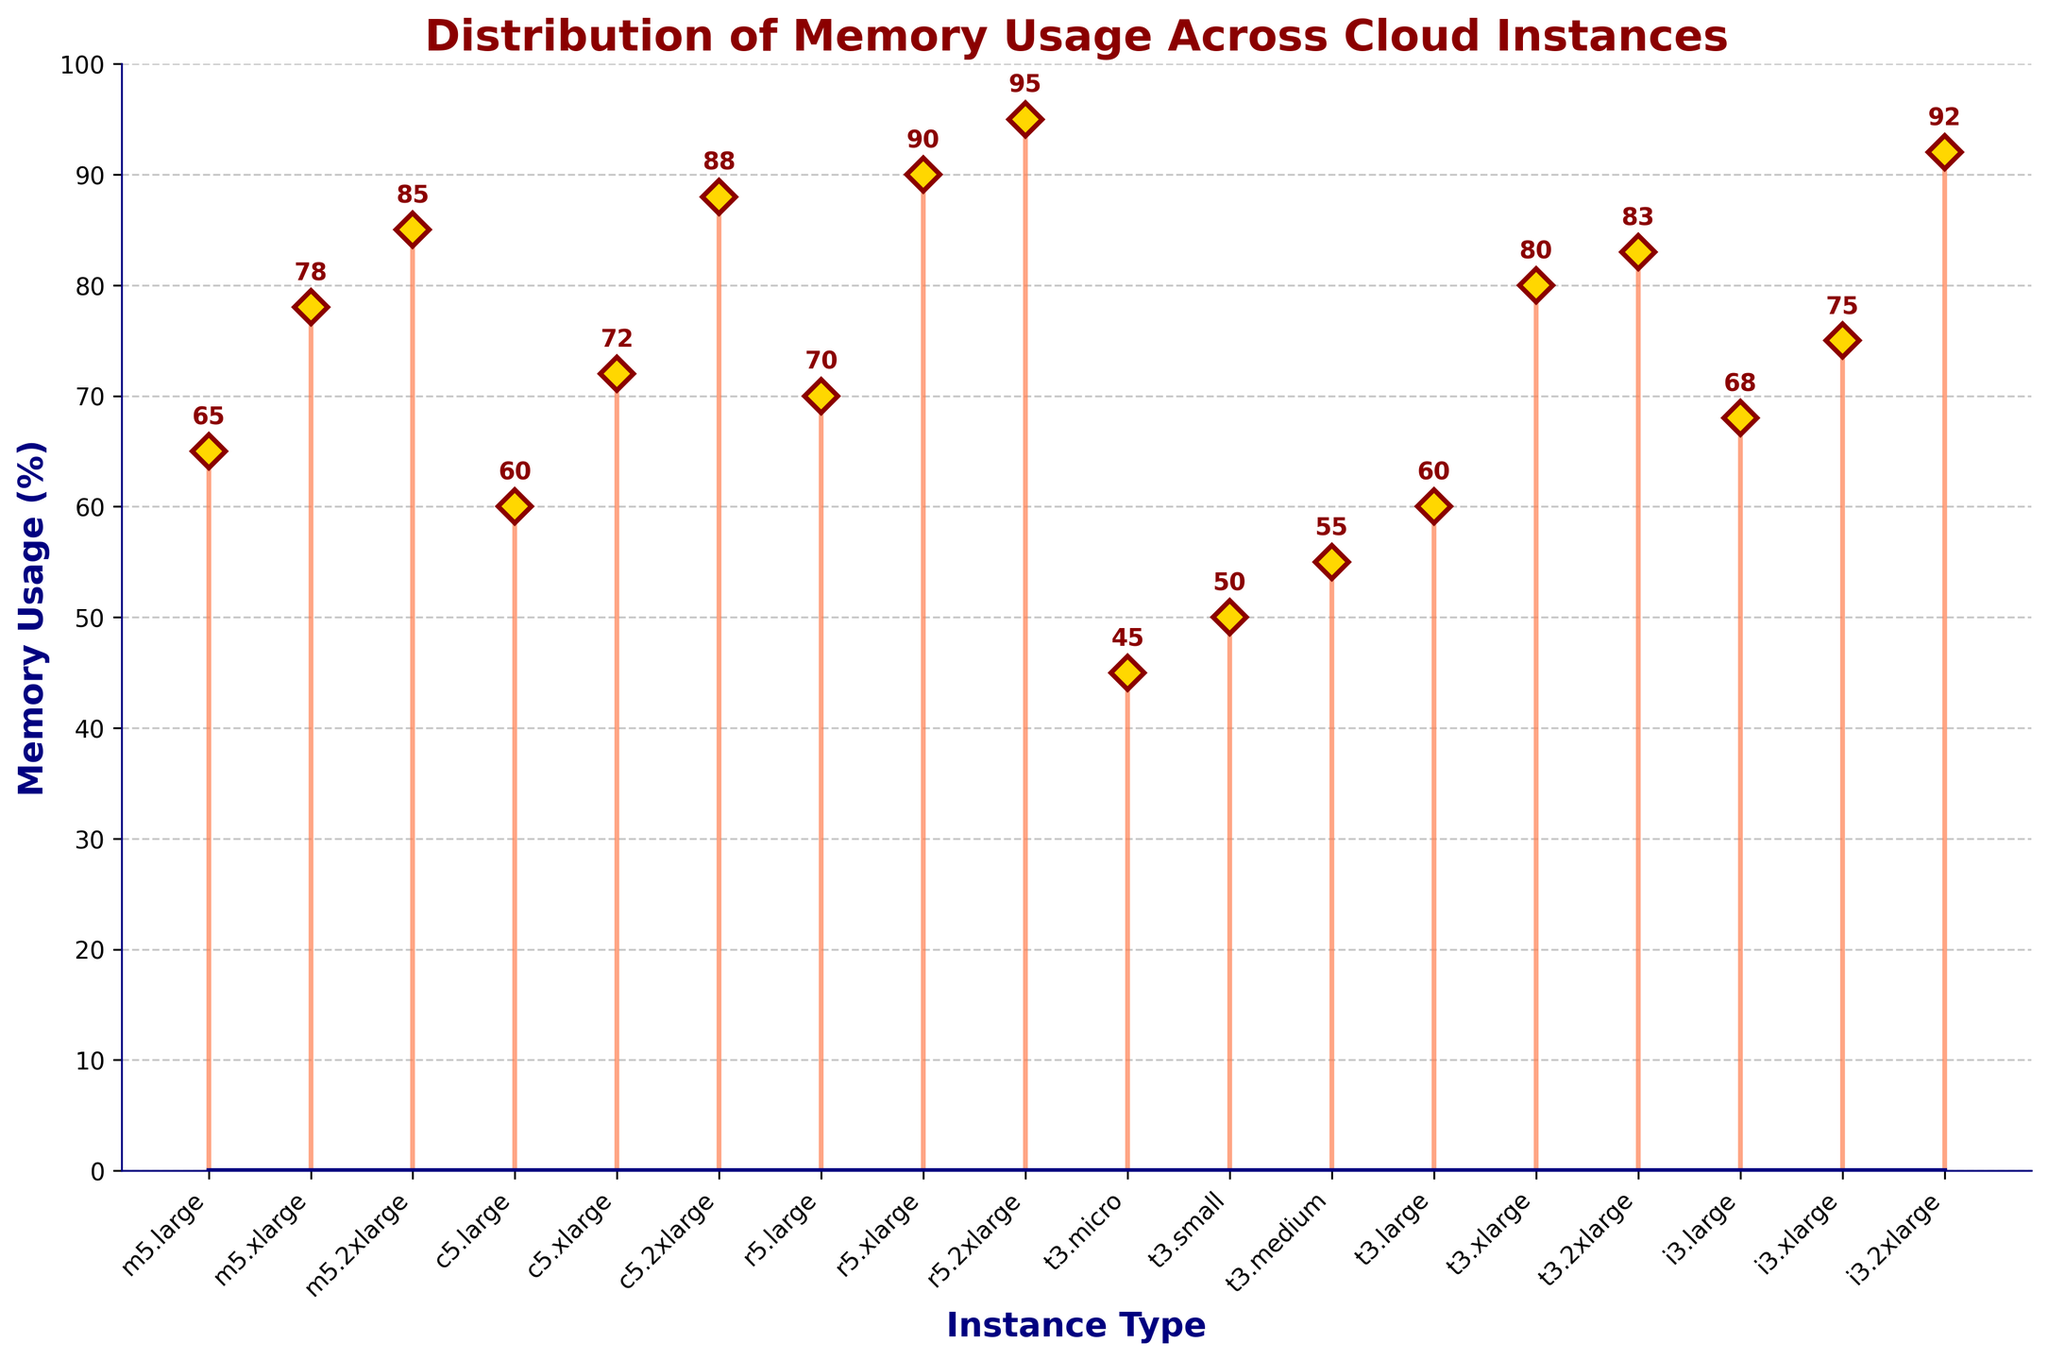What is the title of the figure? The title is usually positioned at the top of the figure and it provides a summary of what the figure is depicting. Here, the title is positioned at the top with a bold, dark red style.
Answer: Distribution of Memory Usage Across Cloud Instances What is the label of the y-axis? The y-axis label is vertically aligned on the left of the plot. It shows the parameter being measured along that axis, in this case, it is in bold navy font.
Answer: Memory Usage (%) How many instance types are shown in the figure? To determine the number of instance types, count the distinct markers on the x-axis. Each marker represents a unique instance type.
Answer: 18 Which instance type has the highest memory usage and what is its value? Locate the highest point on the stem lines, and then refer to the corresponding x-axis label. This will show which instance type has the highest memory usage. The value can be read from the stem and its label.
Answer: r5.2xlarge, 95% What is the average memory usage across all instance types? Add up all the memory usage values and divide by the total number of instance types. The values and their count (18) are visible from the plot.
Answer: (65 + 78 + 85 + 60 + 72 + 88 + 70 + 90 + 95 + 45 + 50 + 55 + 60 + 80 + 83 + 68 + 75 + 92) / 18 = 73% How much more memory usage does `r5.xlarge` have compared to `c5.large`? Find the memory usage values for `r5.xlarge` and `c5.large` from the plot and subtract the value of `c5.large` from `r5.xlarge`.
Answer: r5.xlarge (90%) - c5.large (60%) = 30% Which instance type has the lowest memory usage and what is its value? Locate the lowest point on the stem lines and refer to the corresponding x-axis label for the instance type with the lowest memory usage.
Answer: t3.micro, 45% Are there any instance types with the same memory usage value? Scan through the plot to identify any overlapping memory usage markers. Compare values of adjacent markers, or any markers that are vertically aligned.
Answer: No What is the difference in memory usage between the largest and smallest `m5` instance types? Identify the largest (`m5.2xlarge`) and smallest (`m5.large`) instance types from the `m5` category in the plot, then subtract their memory usage values.
Answer: m5.2xlarge (85%) - m5.large (65%) = 20% Which instance types have a memory usage value greater than 80%? Identify instance types with memory usage values above 80% by looking at the higher end of the y-axis. List the corresponding x-axis labels.
Answer: m5.2xlarge, c5.2xlarge, r5.xlarge, r5.2xlarge, t3.xlarge, t3.2xlarge, i3.2xlarge 